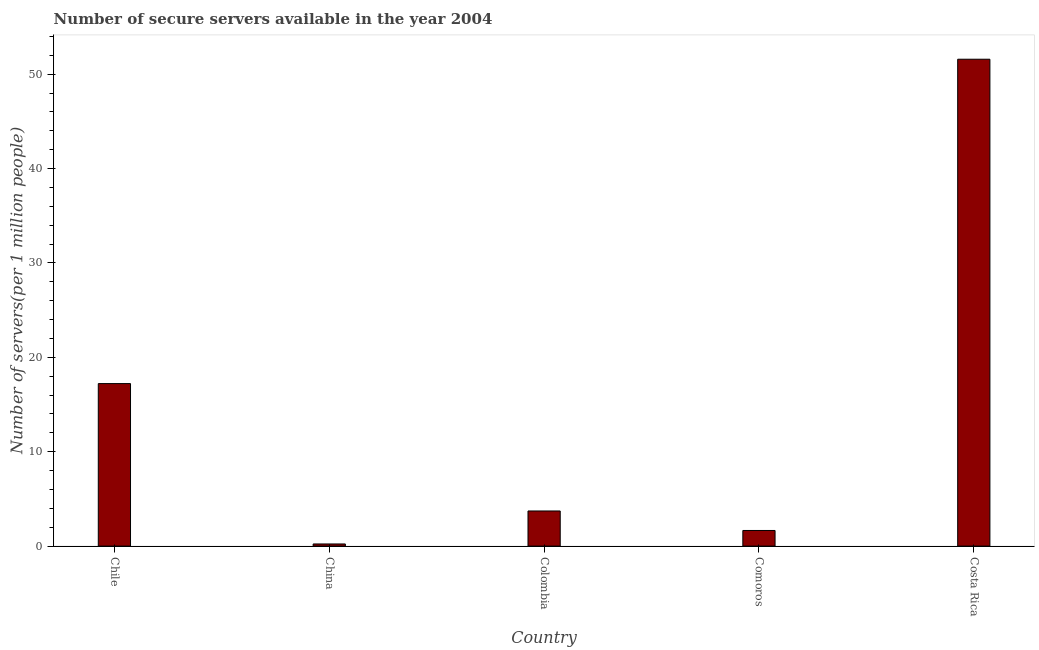Does the graph contain grids?
Provide a succinct answer. No. What is the title of the graph?
Keep it short and to the point. Number of secure servers available in the year 2004. What is the label or title of the X-axis?
Keep it short and to the point. Country. What is the label or title of the Y-axis?
Offer a very short reply. Number of servers(per 1 million people). What is the number of secure internet servers in Chile?
Keep it short and to the point. 17.22. Across all countries, what is the maximum number of secure internet servers?
Ensure brevity in your answer.  51.59. Across all countries, what is the minimum number of secure internet servers?
Offer a terse response. 0.23. What is the sum of the number of secure internet servers?
Provide a succinct answer. 74.41. What is the difference between the number of secure internet servers in Chile and Costa Rica?
Your response must be concise. -34.37. What is the average number of secure internet servers per country?
Keep it short and to the point. 14.88. What is the median number of secure internet servers?
Offer a terse response. 3.72. What is the ratio of the number of secure internet servers in Chile to that in Costa Rica?
Ensure brevity in your answer.  0.33. Is the number of secure internet servers in China less than that in Comoros?
Your answer should be very brief. Yes. Is the difference between the number of secure internet servers in China and Colombia greater than the difference between any two countries?
Give a very brief answer. No. What is the difference between the highest and the second highest number of secure internet servers?
Offer a terse response. 34.37. Is the sum of the number of secure internet servers in Comoros and Costa Rica greater than the maximum number of secure internet servers across all countries?
Offer a very short reply. Yes. What is the difference between the highest and the lowest number of secure internet servers?
Offer a very short reply. 51.36. In how many countries, is the number of secure internet servers greater than the average number of secure internet servers taken over all countries?
Make the answer very short. 2. Are all the bars in the graph horizontal?
Provide a succinct answer. No. What is the difference between two consecutive major ticks on the Y-axis?
Keep it short and to the point. 10. What is the Number of servers(per 1 million people) in Chile?
Ensure brevity in your answer.  17.22. What is the Number of servers(per 1 million people) of China?
Ensure brevity in your answer.  0.23. What is the Number of servers(per 1 million people) of Colombia?
Your response must be concise. 3.72. What is the Number of servers(per 1 million people) in Comoros?
Offer a terse response. 1.66. What is the Number of servers(per 1 million people) of Costa Rica?
Offer a very short reply. 51.59. What is the difference between the Number of servers(per 1 million people) in Chile and China?
Provide a succinct answer. 16.99. What is the difference between the Number of servers(per 1 million people) in Chile and Colombia?
Provide a short and direct response. 13.5. What is the difference between the Number of servers(per 1 million people) in Chile and Comoros?
Keep it short and to the point. 15.56. What is the difference between the Number of servers(per 1 million people) in Chile and Costa Rica?
Your response must be concise. -34.37. What is the difference between the Number of servers(per 1 million people) in China and Colombia?
Make the answer very short. -3.5. What is the difference between the Number of servers(per 1 million people) in China and Comoros?
Give a very brief answer. -1.43. What is the difference between the Number of servers(per 1 million people) in China and Costa Rica?
Provide a short and direct response. -51.36. What is the difference between the Number of servers(per 1 million people) in Colombia and Comoros?
Keep it short and to the point. 2.07. What is the difference between the Number of servers(per 1 million people) in Colombia and Costa Rica?
Make the answer very short. -47.87. What is the difference between the Number of servers(per 1 million people) in Comoros and Costa Rica?
Keep it short and to the point. -49.93. What is the ratio of the Number of servers(per 1 million people) in Chile to that in China?
Offer a terse response. 76.17. What is the ratio of the Number of servers(per 1 million people) in Chile to that in Colombia?
Provide a succinct answer. 4.63. What is the ratio of the Number of servers(per 1 million people) in Chile to that in Comoros?
Make the answer very short. 10.4. What is the ratio of the Number of servers(per 1 million people) in Chile to that in Costa Rica?
Offer a terse response. 0.33. What is the ratio of the Number of servers(per 1 million people) in China to that in Colombia?
Your response must be concise. 0.06. What is the ratio of the Number of servers(per 1 million people) in China to that in Comoros?
Offer a very short reply. 0.14. What is the ratio of the Number of servers(per 1 million people) in China to that in Costa Rica?
Offer a terse response. 0. What is the ratio of the Number of servers(per 1 million people) in Colombia to that in Comoros?
Give a very brief answer. 2.25. What is the ratio of the Number of servers(per 1 million people) in Colombia to that in Costa Rica?
Your answer should be very brief. 0.07. What is the ratio of the Number of servers(per 1 million people) in Comoros to that in Costa Rica?
Keep it short and to the point. 0.03. 